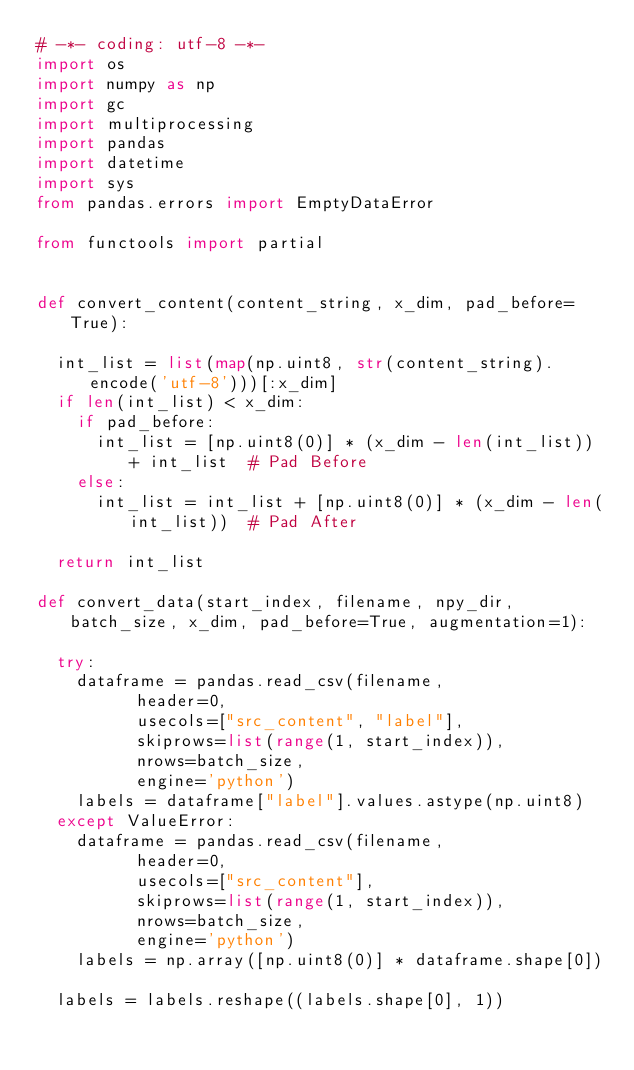Convert code to text. <code><loc_0><loc_0><loc_500><loc_500><_Python_># -*- coding: utf-8 -*-
import os
import numpy as np
import gc
import multiprocessing
import pandas
import datetime
import sys
from pandas.errors import EmptyDataError

from functools import partial


def convert_content(content_string, x_dim, pad_before=True):

	int_list = list(map(np.uint8, str(content_string).encode('utf-8')))[:x_dim]
	if len(int_list) < x_dim:
		if pad_before:
			int_list = [np.uint8(0)] * (x_dim - len(int_list)) + int_list  # Pad Before
		else:
			int_list = int_list + [np.uint8(0)] * (x_dim - len(int_list))  # Pad After

	return int_list

def convert_data(start_index, filename, npy_dir, batch_size, x_dim, pad_before=True, augmentation=1):

	try:
		dataframe = pandas.read_csv(filename,
					header=0,
					usecols=["src_content", "label"],
					skiprows=list(range(1, start_index)),
					nrows=batch_size,
					engine='python')
		labels = dataframe["label"].values.astype(np.uint8)
	except ValueError:
		dataframe = pandas.read_csv(filename,
					header=0,
					usecols=["src_content"],
					skiprows=list(range(1, start_index)),
					nrows=batch_size,
					engine='python')
		labels = np.array([np.uint8(0)] * dataframe.shape[0])

	labels = labels.reshape((labels.shape[0], 1))</code> 